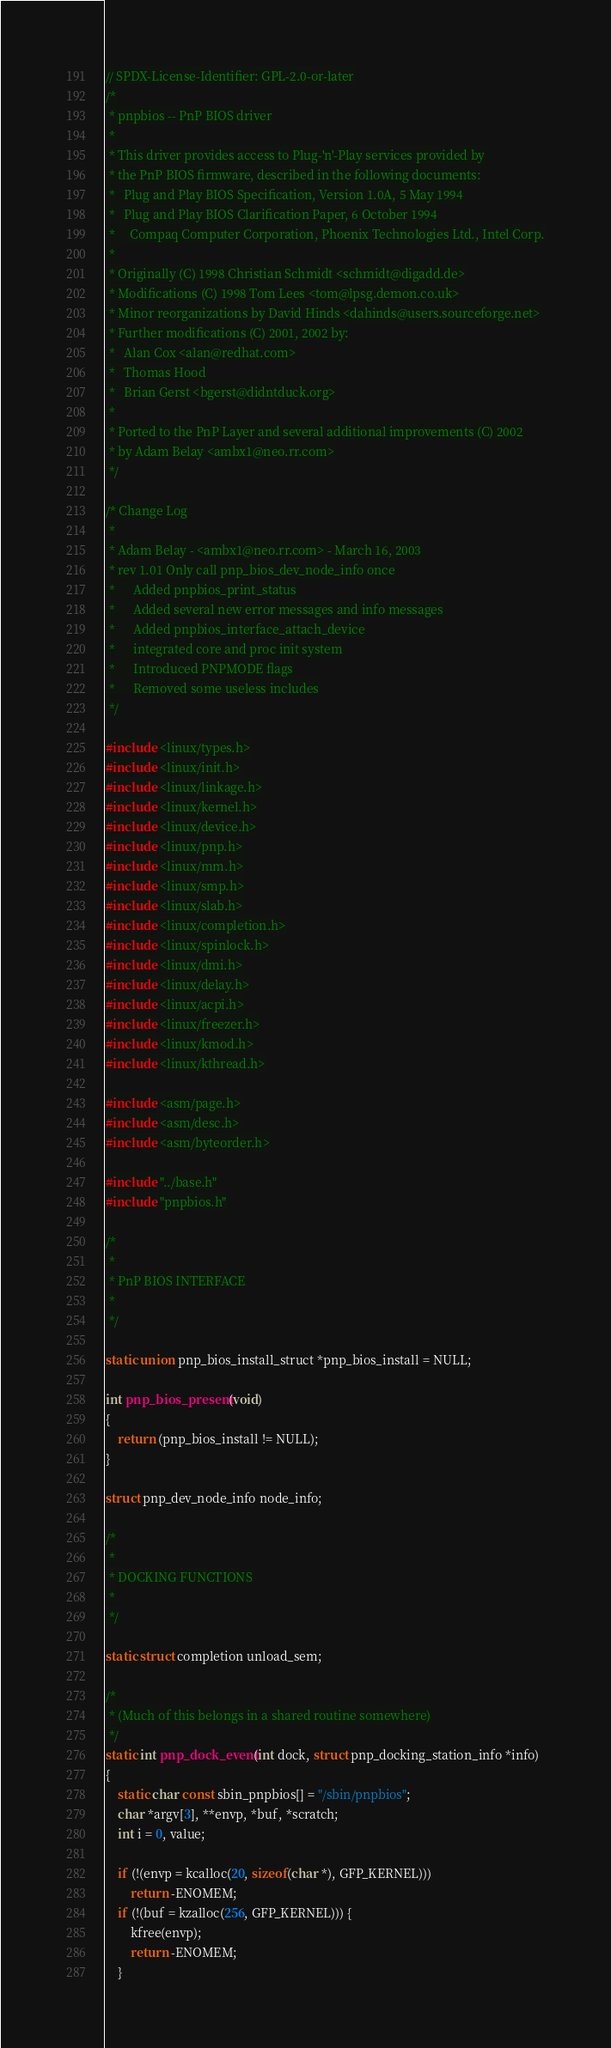Convert code to text. <code><loc_0><loc_0><loc_500><loc_500><_C_>// SPDX-License-Identifier: GPL-2.0-or-later
/*
 * pnpbios -- PnP BIOS driver
 *
 * This driver provides access to Plug-'n'-Play services provided by
 * the PnP BIOS firmware, described in the following documents:
 *   Plug and Play BIOS Specification, Version 1.0A, 5 May 1994
 *   Plug and Play BIOS Clarification Paper, 6 October 1994
 *     Compaq Computer Corporation, Phoenix Technologies Ltd., Intel Corp.
 * 
 * Originally (C) 1998 Christian Schmidt <schmidt@digadd.de>
 * Modifications (C) 1998 Tom Lees <tom@lpsg.demon.co.uk>
 * Minor reorganizations by David Hinds <dahinds@users.sourceforge.net>
 * Further modifications (C) 2001, 2002 by:
 *   Alan Cox <alan@redhat.com>
 *   Thomas Hood
 *   Brian Gerst <bgerst@didntduck.org>
 *
 * Ported to the PnP Layer and several additional improvements (C) 2002
 * by Adam Belay <ambx1@neo.rr.com>
 */

/* Change Log
 *
 * Adam Belay - <ambx1@neo.rr.com> - March 16, 2003
 * rev 1.01	Only call pnp_bios_dev_node_info once
 *		Added pnpbios_print_status
 *		Added several new error messages and info messages
 *		Added pnpbios_interface_attach_device
 *		integrated core and proc init system
 *		Introduced PNPMODE flags
 *		Removed some useless includes
 */

#include <linux/types.h>
#include <linux/init.h>
#include <linux/linkage.h>
#include <linux/kernel.h>
#include <linux/device.h>
#include <linux/pnp.h>
#include <linux/mm.h>
#include <linux/smp.h>
#include <linux/slab.h>
#include <linux/completion.h>
#include <linux/spinlock.h>
#include <linux/dmi.h>
#include <linux/delay.h>
#include <linux/acpi.h>
#include <linux/freezer.h>
#include <linux/kmod.h>
#include <linux/kthread.h>

#include <asm/page.h>
#include <asm/desc.h>
#include <asm/byteorder.h>

#include "../base.h"
#include "pnpbios.h"

/*
 *
 * PnP BIOS INTERFACE
 *
 */

static union pnp_bios_install_struct *pnp_bios_install = NULL;

int pnp_bios_present(void)
{
	return (pnp_bios_install != NULL);
}

struct pnp_dev_node_info node_info;

/*
 *
 * DOCKING FUNCTIONS
 *
 */

static struct completion unload_sem;

/*
 * (Much of this belongs in a shared routine somewhere)
 */
static int pnp_dock_event(int dock, struct pnp_docking_station_info *info)
{
	static char const sbin_pnpbios[] = "/sbin/pnpbios";
	char *argv[3], **envp, *buf, *scratch;
	int i = 0, value;

	if (!(envp = kcalloc(20, sizeof(char *), GFP_KERNEL)))
		return -ENOMEM;
	if (!(buf = kzalloc(256, GFP_KERNEL))) {
		kfree(envp);
		return -ENOMEM;
	}
</code> 